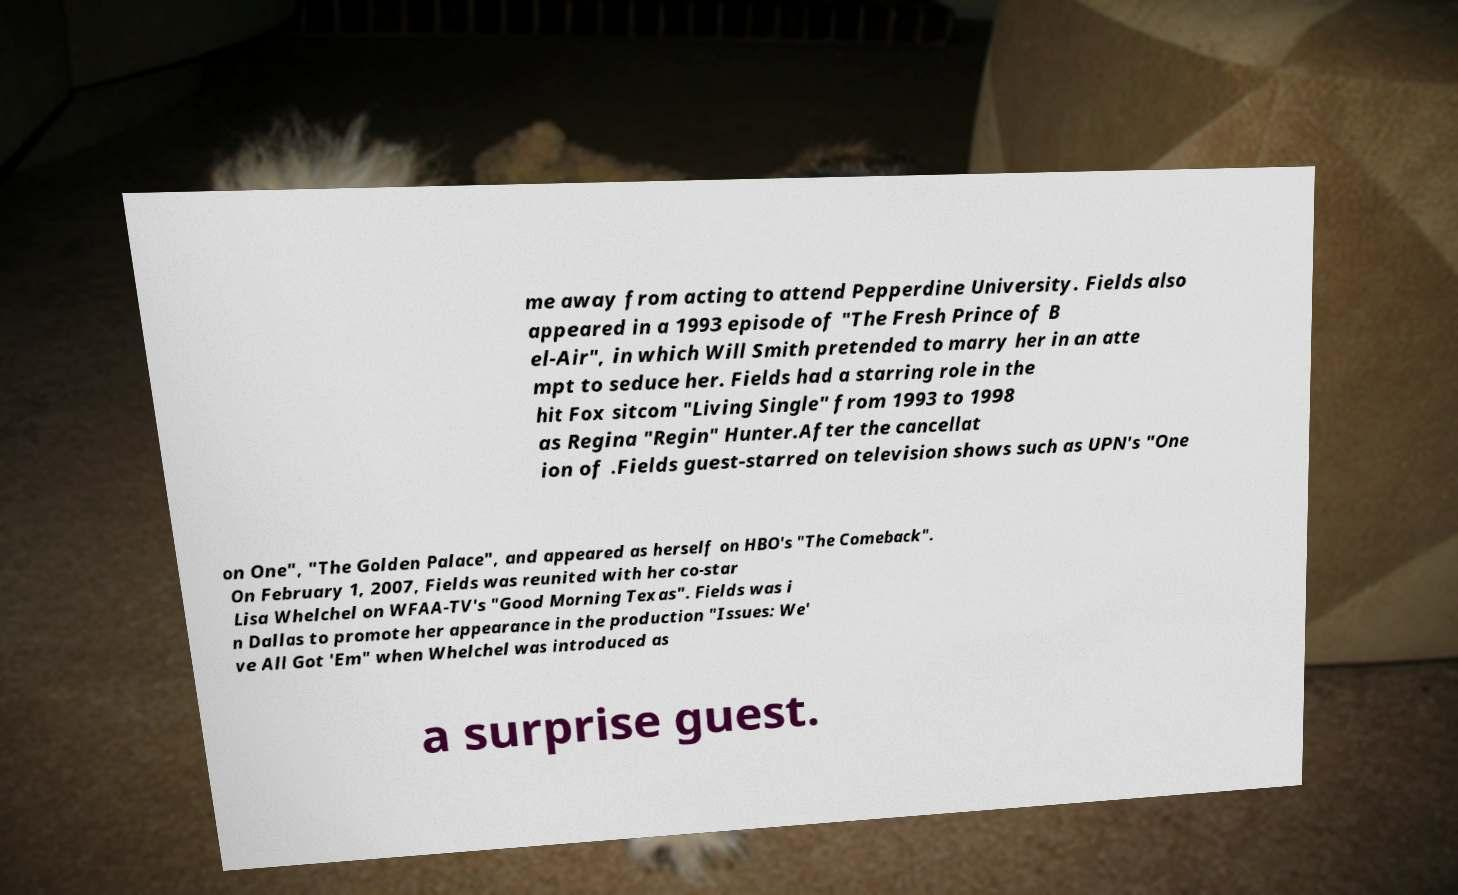Can you read and provide the text displayed in the image?This photo seems to have some interesting text. Can you extract and type it out for me? me away from acting to attend Pepperdine University. Fields also appeared in a 1993 episode of "The Fresh Prince of B el-Air", in which Will Smith pretended to marry her in an atte mpt to seduce her. Fields had a starring role in the hit Fox sitcom "Living Single" from 1993 to 1998 as Regina "Regin" Hunter.After the cancellat ion of .Fields guest-starred on television shows such as UPN's "One on One", "The Golden Palace", and appeared as herself on HBO's "The Comeback". On February 1, 2007, Fields was reunited with her co-star Lisa Whelchel on WFAA-TV's "Good Morning Texas". Fields was i n Dallas to promote her appearance in the production "Issues: We' ve All Got 'Em" when Whelchel was introduced as a surprise guest. 